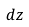<formula> <loc_0><loc_0><loc_500><loc_500>d z</formula> 